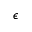Convert formula to latex. <formula><loc_0><loc_0><loc_500><loc_500>\epsilon</formula> 